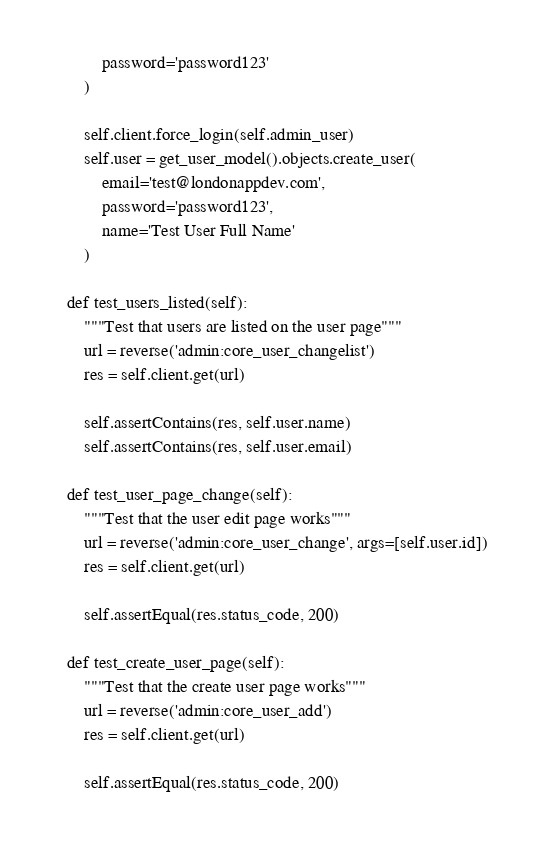<code> <loc_0><loc_0><loc_500><loc_500><_Python_>            password='password123'
        )

        self.client.force_login(self.admin_user)
        self.user = get_user_model().objects.create_user(
            email='test@londonappdev.com',
            password='password123',
            name='Test User Full Name'
        )

    def test_users_listed(self):
        """Test that users are listed on the user page"""
        url = reverse('admin:core_user_changelist')
        res = self.client.get(url)

        self.assertContains(res, self.user.name)
        self.assertContains(res, self.user.email)

    def test_user_page_change(self):
        """Test that the user edit page works"""
        url = reverse('admin:core_user_change', args=[self.user.id])
        res = self.client.get(url)

        self.assertEqual(res.status_code, 200)

    def test_create_user_page(self):
        """Test that the create user page works"""
        url = reverse('admin:core_user_add')
        res = self.client.get(url)

        self.assertEqual(res.status_code, 200)
</code> 